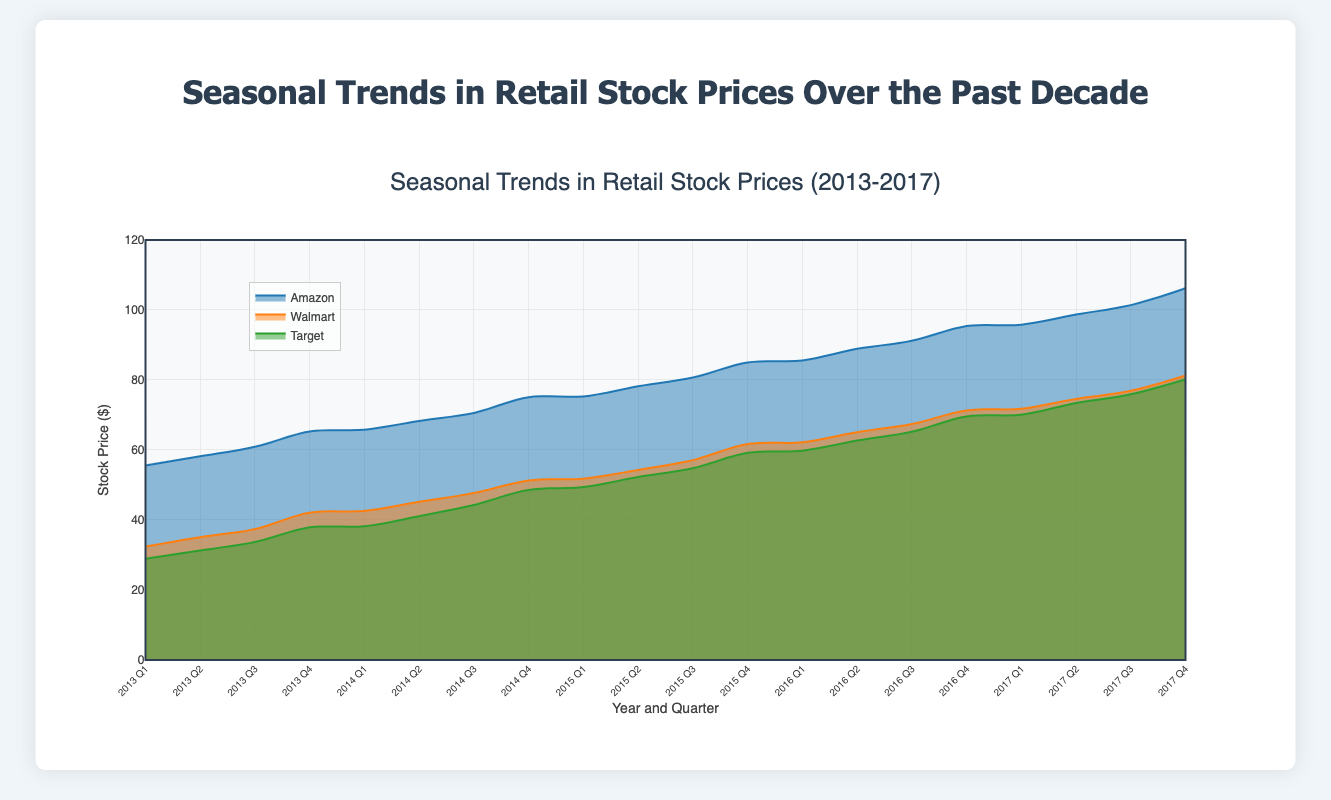What's the title of the chart? The title is shown prominently at the top of the chart and reads "Seasonal Trends in Retail Stock Prices Over the Past Decade".
Answer: Seasonal Trends in Retail Stock Prices Over the Past Decade Which stock had the highest price in Q4 of 2017? According to the chart, in Q4 of 2017, Amazon's stock price reaches around 106.2 while Walmart and Target are at 81.3 and 80.2 respectively.
Answer: Amazon Is there a visible trend in Amazon's stock price from 2013 to 2017? By observing the area chart, Amazon's stock price shows a consistent upward trend from 2013 to 2017 across all quarters.
Answer: Yes How does Walmart’s stock price change from Q1 to Q4 in 2015? Walmart's stock price steadily increases from 51.8 in Q1 to 61.7 in Q4 of 2015 as observed from the increasing area in the chart.
Answer: It increases Compare Target’s stock price in Q3 2014 and Q3 2016. Which is higher? In Q3 of 2014, Target's stock price is 44.3, while in Q3 of 2016, it is 65.2. Therefore, Q3 2016 is higher than Q3 2014.
Answer: Q3 2016 What is the general pattern of stock prices in the fourth quarters? For all three companies (Amazon, Walmart, Target), the fourth quarters tend to have higher stock prices compared to the other quarters, indicating a trend of increasing stock values towards the end of the year.
Answer: Higher What's the average stock price of Walmart for the year 2016? Walmart's stock prices for the year 2016 are 62.2 (Q1), 65.1 (Q2), 67.4 (Q3), and 71.3 (Q4). The average is calculated as: (62.2 + 65.1 + 67.4 + 71.3) / 4 = 66.5.
Answer: 66.5 Which stock consistently shows the highest stock prices across all quarters? By comparing the areas for each stock, Amazon consistently has the highest stock prices across all quarters from 2013 to 2017.
Answer: Amazon What's the difference between Amazon and Walmart's stock prices in Q2 of 2014? For Q2 of 2014, Amazon's stock price is 68.3 while Walmart's stock price is 45.2. The difference is 68.3 - 45.2 = 23.1.
Answer: 23.1 What can you infer about the seasonal effect on stock prices based on the chart? The chart shows an increase in stock prices towards the end of each year (Q4) for Amazon, Walmart, and Target, suggesting a strong seasonal effect likely influenced by holiday sales and shopping seasons.
Answer: Increased prices in Q4 